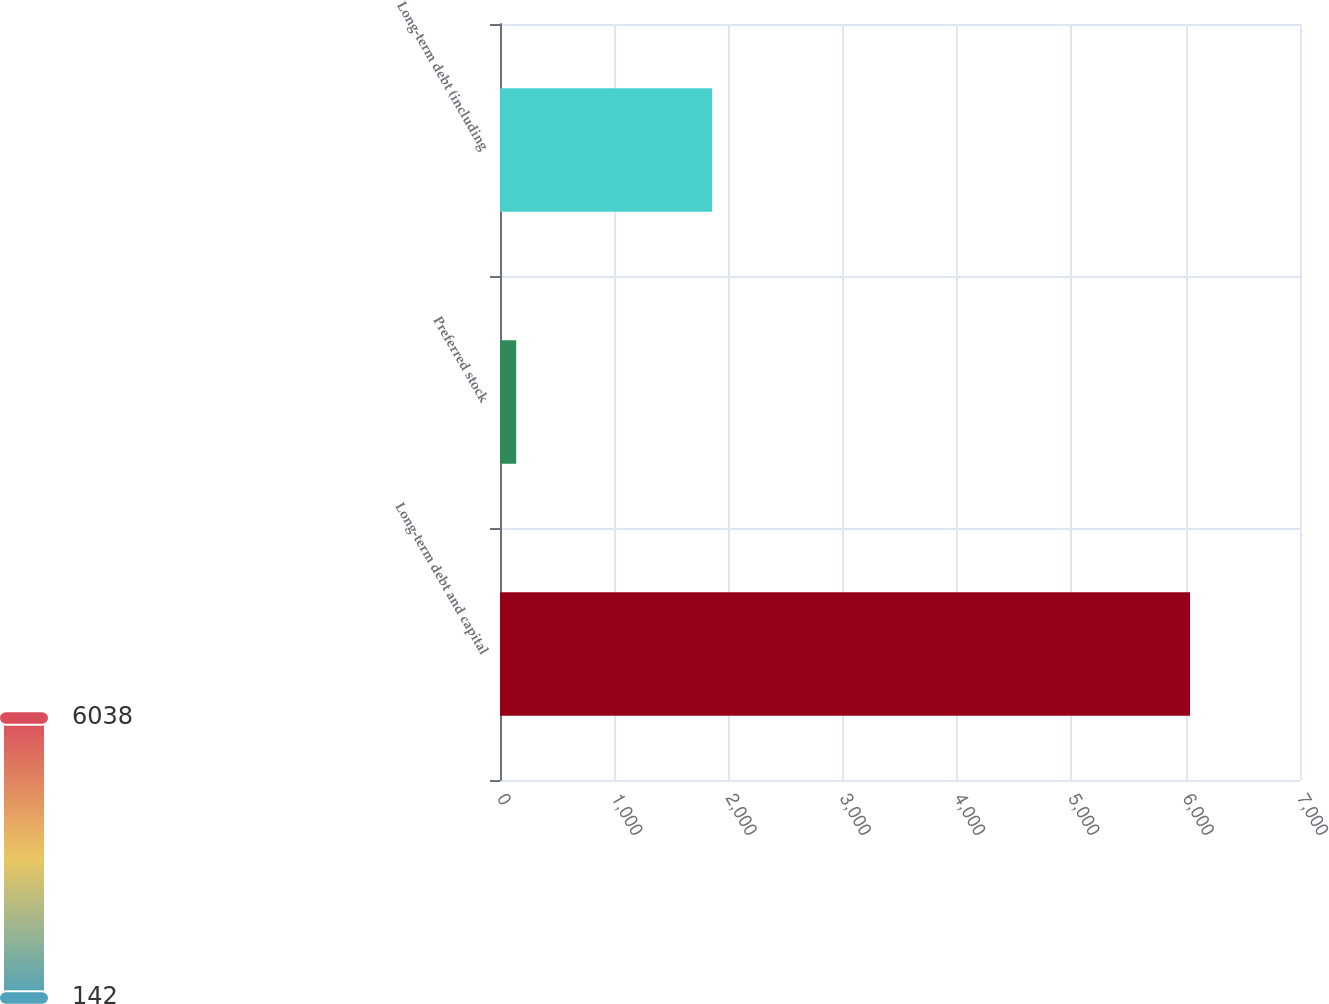<chart> <loc_0><loc_0><loc_500><loc_500><bar_chart><fcel>Long-term debt and capital<fcel>Preferred stock<fcel>Long-term debt (including<nl><fcel>6038<fcel>142<fcel>1856<nl></chart> 